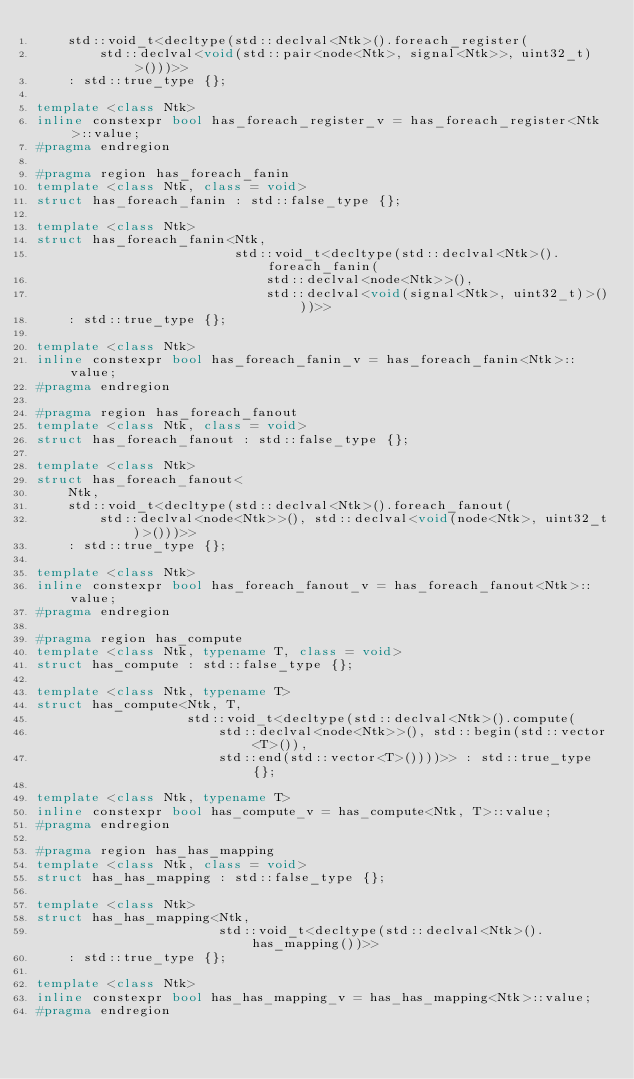Convert code to text. <code><loc_0><loc_0><loc_500><loc_500><_C++_>    std::void_t<decltype(std::declval<Ntk>().foreach_register(
        std::declval<void(std::pair<node<Ntk>, signal<Ntk>>, uint32_t)>()))>>
    : std::true_type {};

template <class Ntk>
inline constexpr bool has_foreach_register_v = has_foreach_register<Ntk>::value;
#pragma endregion

#pragma region has_foreach_fanin
template <class Ntk, class = void>
struct has_foreach_fanin : std::false_type {};

template <class Ntk>
struct has_foreach_fanin<Ntk,
                         std::void_t<decltype(std::declval<Ntk>().foreach_fanin(
                             std::declval<node<Ntk>>(),
                             std::declval<void(signal<Ntk>, uint32_t)>()))>>
    : std::true_type {};

template <class Ntk>
inline constexpr bool has_foreach_fanin_v = has_foreach_fanin<Ntk>::value;
#pragma endregion

#pragma region has_foreach_fanout
template <class Ntk, class = void>
struct has_foreach_fanout : std::false_type {};

template <class Ntk>
struct has_foreach_fanout<
    Ntk,
    std::void_t<decltype(std::declval<Ntk>().foreach_fanout(
        std::declval<node<Ntk>>(), std::declval<void(node<Ntk>, uint32_t)>()))>>
    : std::true_type {};

template <class Ntk>
inline constexpr bool has_foreach_fanout_v = has_foreach_fanout<Ntk>::value;
#pragma endregion

#pragma region has_compute
template <class Ntk, typename T, class = void>
struct has_compute : std::false_type {};

template <class Ntk, typename T>
struct has_compute<Ntk, T,
                   std::void_t<decltype(std::declval<Ntk>().compute(
                       std::declval<node<Ntk>>(), std::begin(std::vector<T>()),
                       std::end(std::vector<T>())))>> : std::true_type {};

template <class Ntk, typename T>
inline constexpr bool has_compute_v = has_compute<Ntk, T>::value;
#pragma endregion

#pragma region has_has_mapping
template <class Ntk, class = void>
struct has_has_mapping : std::false_type {};

template <class Ntk>
struct has_has_mapping<Ntk,
                       std::void_t<decltype(std::declval<Ntk>().has_mapping())>>
    : std::true_type {};

template <class Ntk>
inline constexpr bool has_has_mapping_v = has_has_mapping<Ntk>::value;
#pragma endregion
</code> 